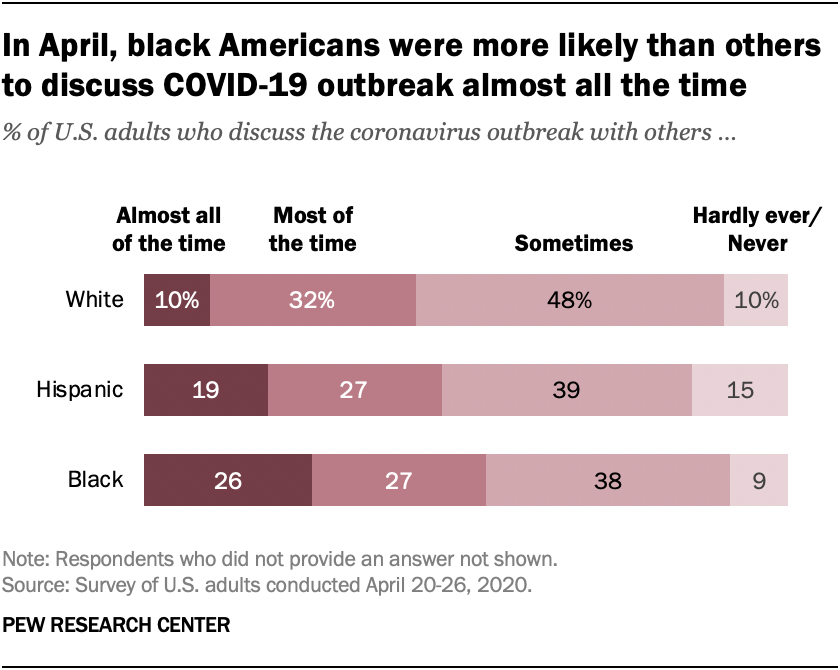Identify some key points in this picture. The sum of those who answered "most of the time" and "almost all of the time" for Hispanics is 46. The lightest shade on the graph represents extremely rare or non-existent instances. 